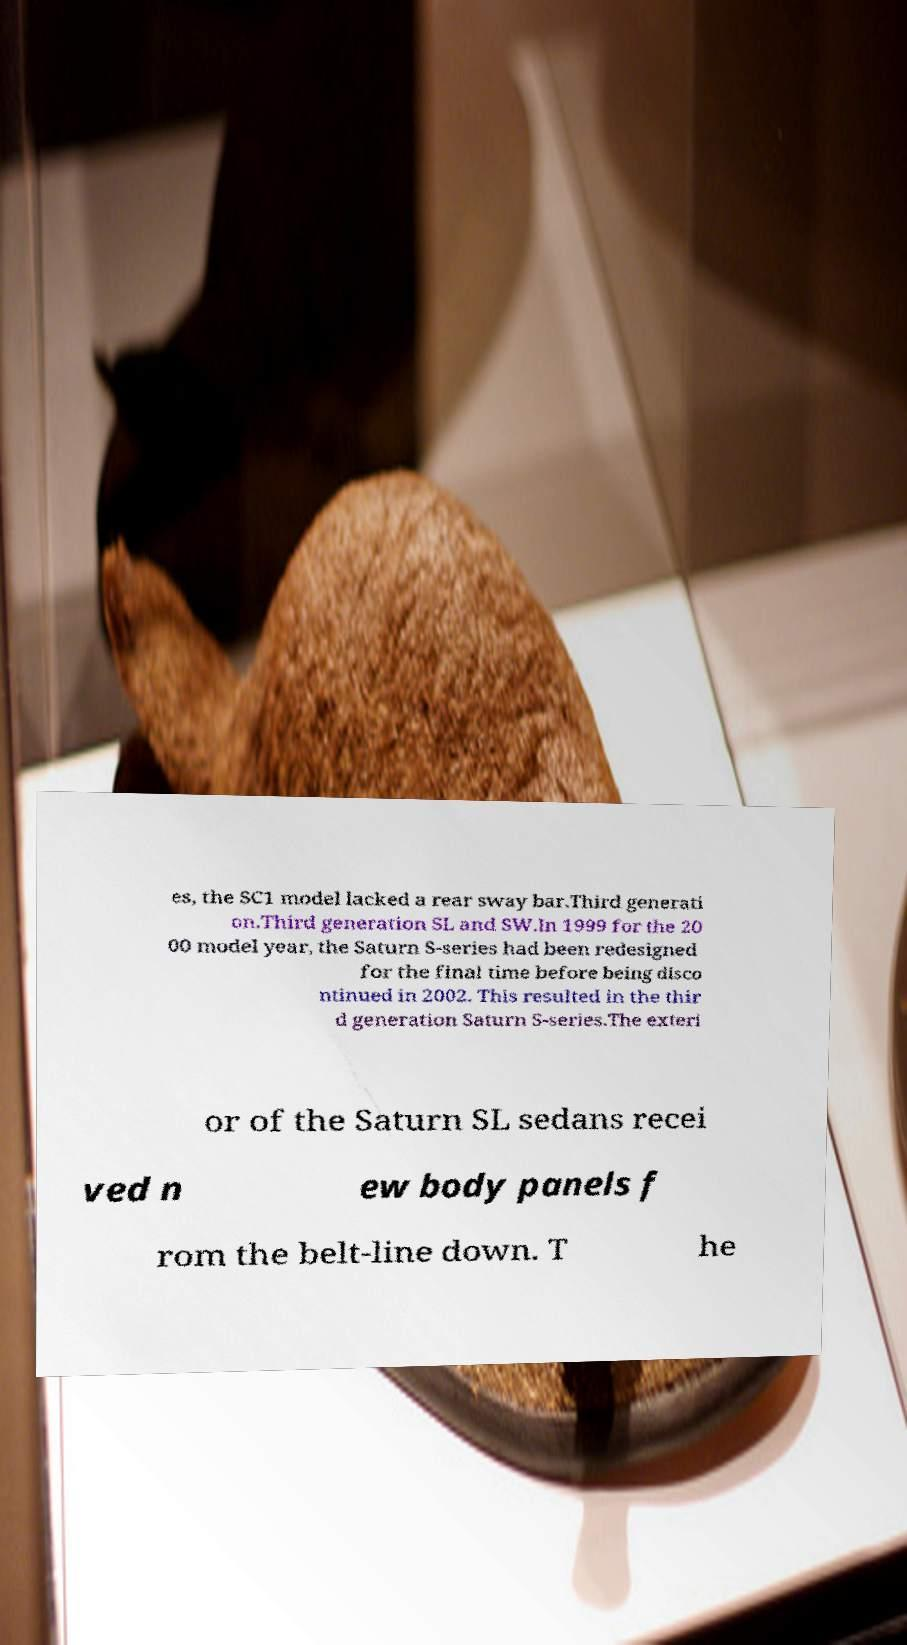Please identify and transcribe the text found in this image. es, the SC1 model lacked a rear sway bar.Third generati on.Third generation SL and SW.In 1999 for the 20 00 model year, the Saturn S-series had been redesigned for the final time before being disco ntinued in 2002. This resulted in the thir d generation Saturn S-series.The exteri or of the Saturn SL sedans recei ved n ew body panels f rom the belt-line down. T he 